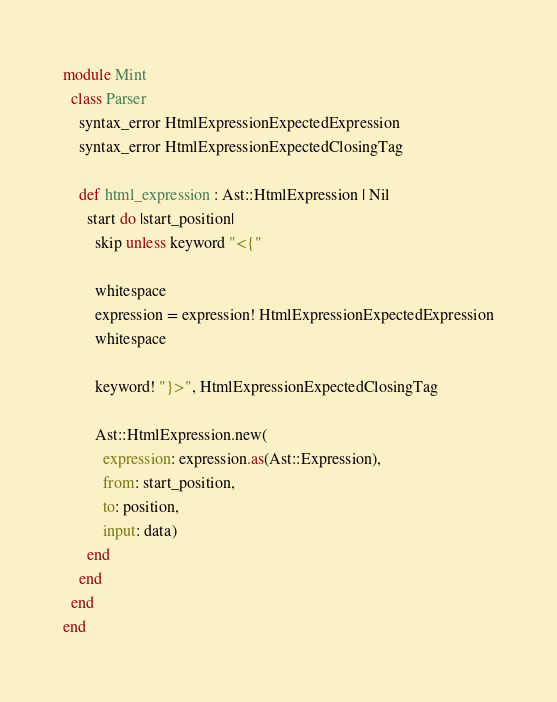Convert code to text. <code><loc_0><loc_0><loc_500><loc_500><_Crystal_>module Mint
  class Parser
    syntax_error HtmlExpressionExpectedExpression
    syntax_error HtmlExpressionExpectedClosingTag

    def html_expression : Ast::HtmlExpression | Nil
      start do |start_position|
        skip unless keyword "<{"

        whitespace
        expression = expression! HtmlExpressionExpectedExpression
        whitespace

        keyword! "}>", HtmlExpressionExpectedClosingTag

        Ast::HtmlExpression.new(
          expression: expression.as(Ast::Expression),
          from: start_position,
          to: position,
          input: data)
      end
    end
  end
end
</code> 